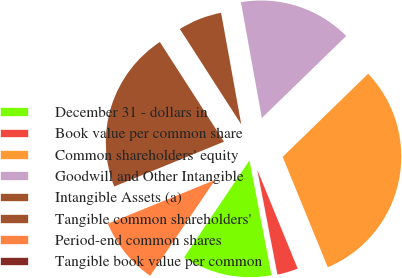Convert chart. <chart><loc_0><loc_0><loc_500><loc_500><pie_chart><fcel>December 31 - dollars in<fcel>Book value per common share<fcel>Common shareholders' equity<fcel>Goodwill and Other Intangible<fcel>Intangible Assets (a)<fcel>Tangible common shareholders'<fcel>Period-end common shares<fcel>Tangible book value per common<nl><fcel>12.46%<fcel>3.15%<fcel>31.1%<fcel>15.57%<fcel>6.25%<fcel>22.07%<fcel>9.36%<fcel>0.04%<nl></chart> 